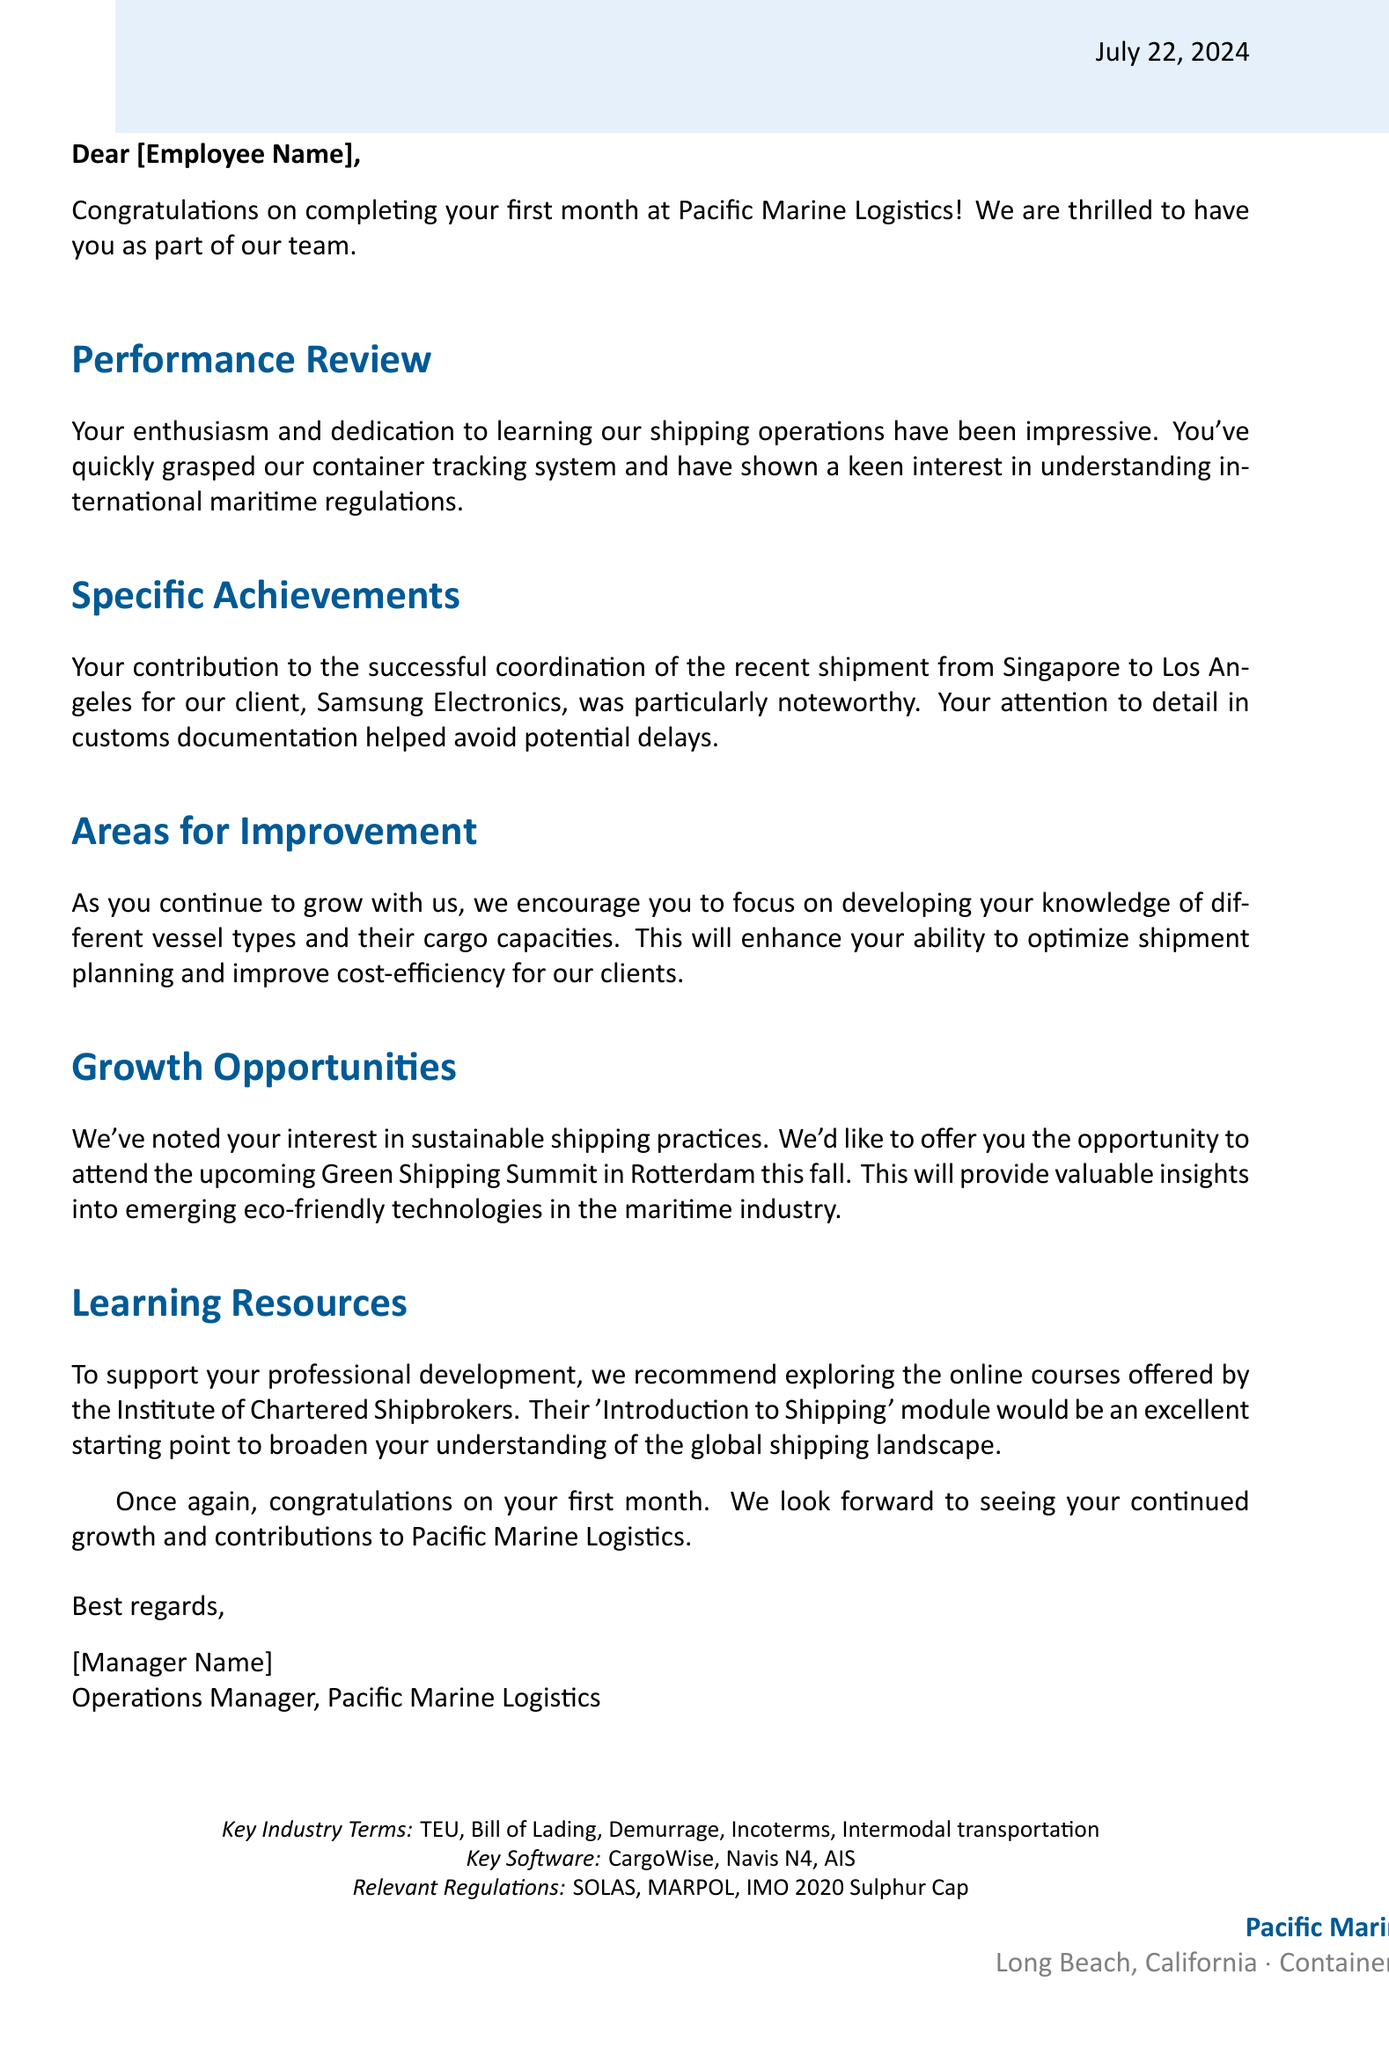What is the name of the company? The company is explicitly stated in the letter as "Pacific Marine Logistics."
Answer: Pacific Marine Logistics Where is the company located? The location of the company is provided in the document as "Long Beach, California."
Answer: Long Beach, California What significant shipment was mentioned in the letter? The letter discusses a shipment from Singapore to Los Angeles for the client Samsung Electronics.
Answer: Singapore to Los Angeles What is one area for improvement suggested in the letter? The letter suggests developing knowledge of different vessel types and cargo capacities as an area for improvement.
Answer: Different vessel types and cargo capacities What opportunity is offered to support sustainable shipping practices? The document states that the opportunity offered is to attend the Green Shipping Summit in Rotterdam.
Answer: Green Shipping Summit in Rotterdam Who is the letter addressed to? The salutation includes a placeholder for the recipient's name, indicated as "[Employee Name]."
Answer: [Employee Name] What education resource is recommended in the letter? The letter recommends exploring online courses by the Institute of Chartered Shipbrokers, specifically their 'Introduction to Shipping' module.
Answer: Institute of Chartered Shipbrokers Who signed the letter? The letter is signed by the Operations Manager of the company, whose name is indicated as "[Manager Name]."
Answer: [Manager Name] What key software is mentioned? The document lists several software tools, including "CargoWise."
Answer: CargoWise 